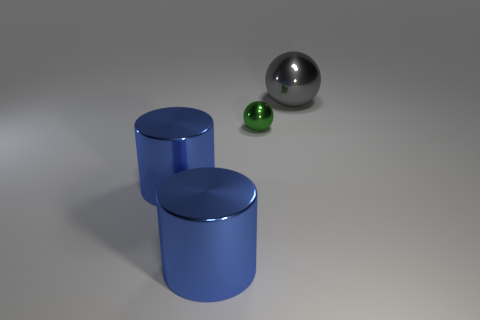Add 1 tiny green spheres. How many objects exist? 5 Subtract 1 balls. How many balls are left? 1 Subtract all gray balls. How many balls are left? 1 Subtract all gray rubber cubes. Subtract all green metal things. How many objects are left? 3 Add 2 green balls. How many green balls are left? 3 Add 3 tiny green metallic things. How many tiny green metallic things exist? 4 Subtract 0 brown cylinders. How many objects are left? 4 Subtract all blue spheres. Subtract all blue cubes. How many spheres are left? 2 